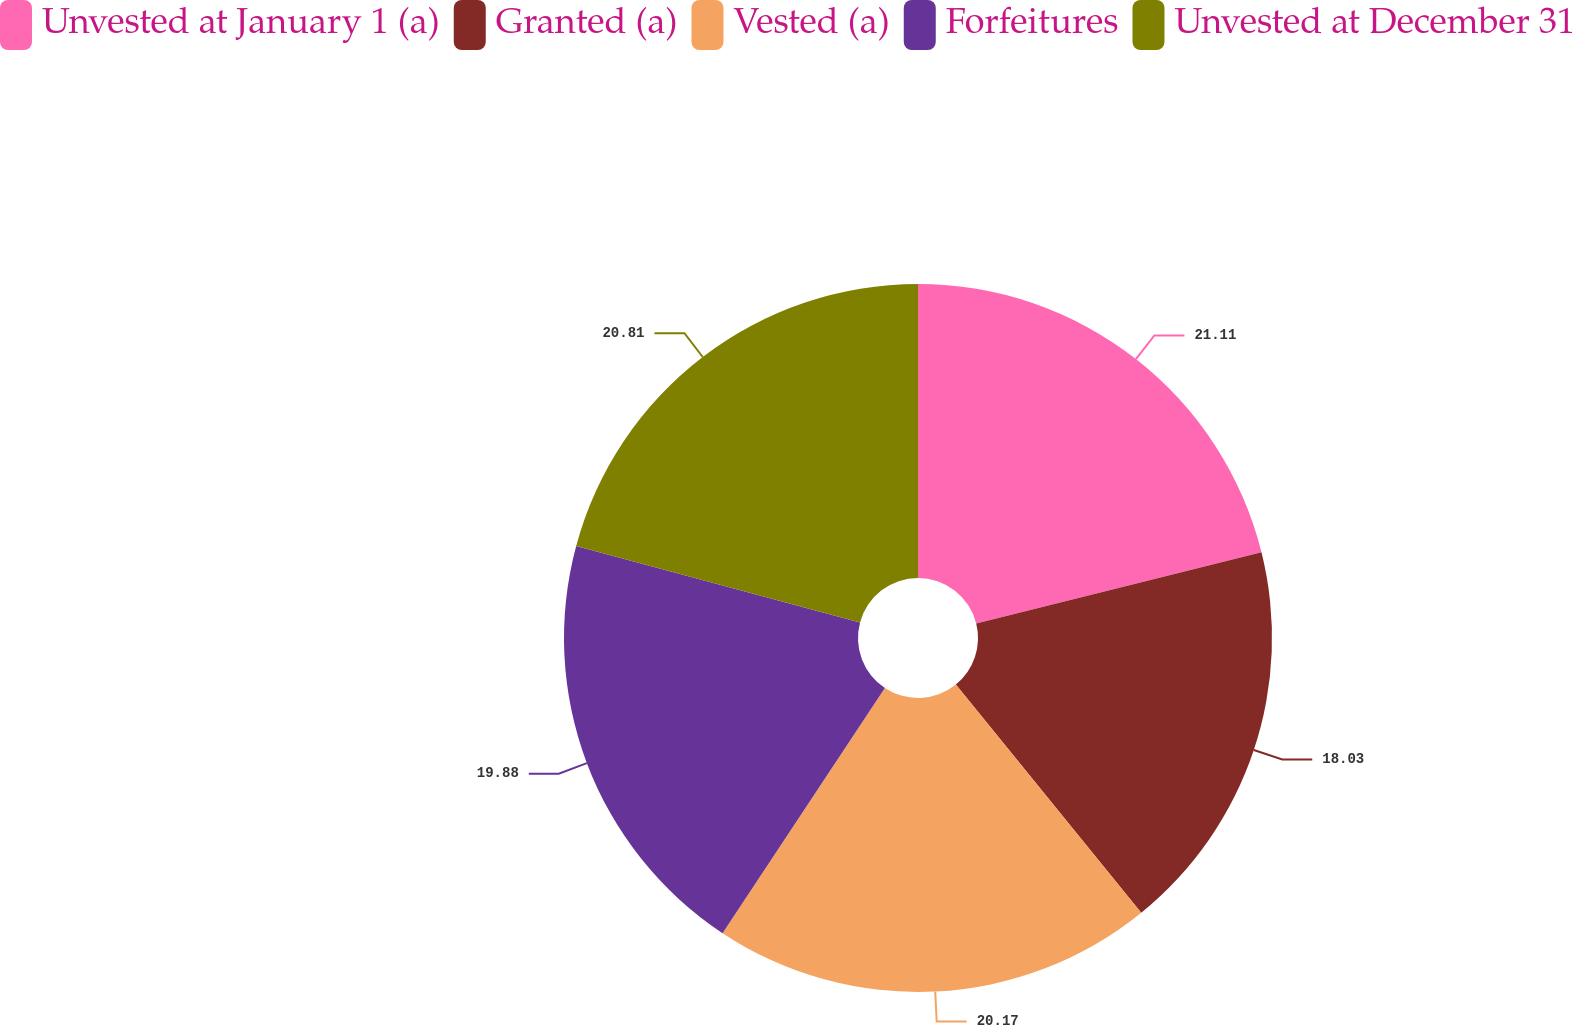<chart> <loc_0><loc_0><loc_500><loc_500><pie_chart><fcel>Unvested at January 1 (a)<fcel>Granted (a)<fcel>Vested (a)<fcel>Forfeitures<fcel>Unvested at December 31<nl><fcel>21.11%<fcel>18.03%<fcel>20.17%<fcel>19.88%<fcel>20.81%<nl></chart> 